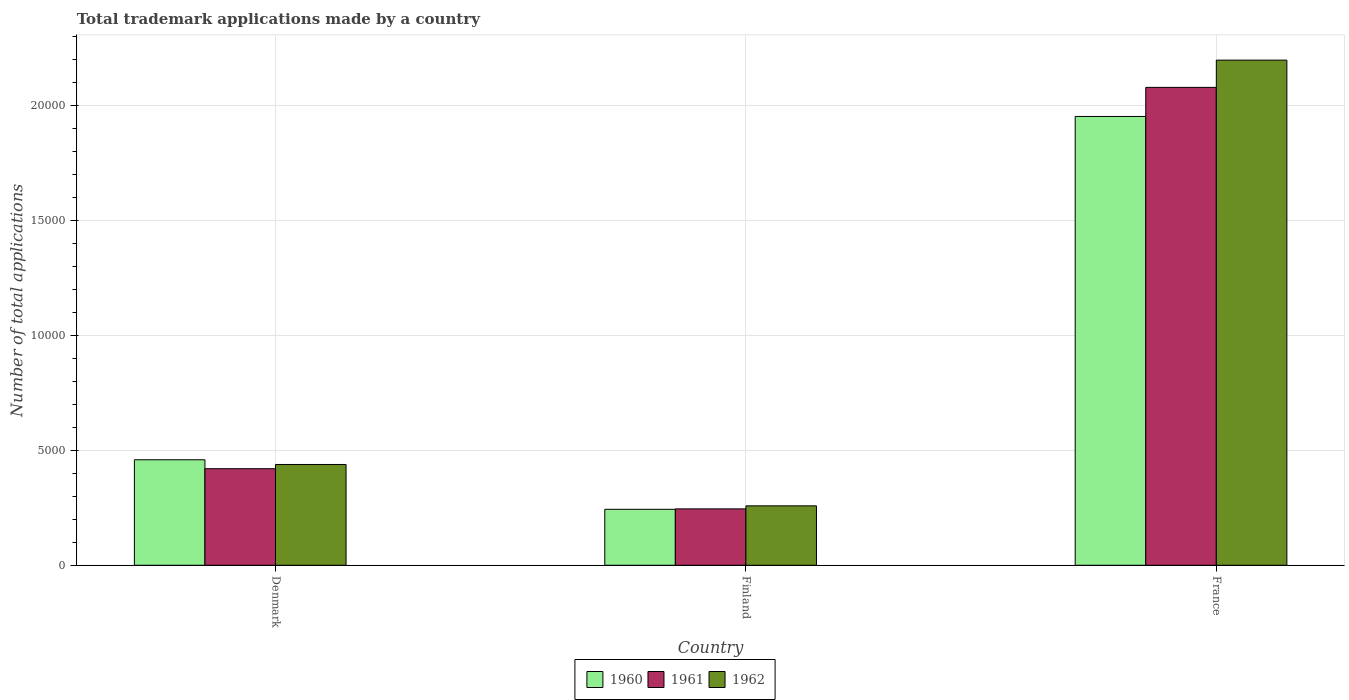How many different coloured bars are there?
Make the answer very short. 3. Are the number of bars per tick equal to the number of legend labels?
Give a very brief answer. Yes. Are the number of bars on each tick of the X-axis equal?
Provide a succinct answer. Yes. How many bars are there on the 3rd tick from the right?
Offer a terse response. 3. What is the number of applications made by in 1961 in France?
Keep it short and to the point. 2.08e+04. Across all countries, what is the maximum number of applications made by in 1962?
Your response must be concise. 2.20e+04. Across all countries, what is the minimum number of applications made by in 1960?
Ensure brevity in your answer.  2432. In which country was the number of applications made by in 1960 minimum?
Ensure brevity in your answer.  Finland. What is the total number of applications made by in 1960 in the graph?
Keep it short and to the point. 2.65e+04. What is the difference between the number of applications made by in 1962 in Finland and that in France?
Offer a very short reply. -1.94e+04. What is the difference between the number of applications made by in 1961 in Finland and the number of applications made by in 1962 in Denmark?
Ensure brevity in your answer.  -1930. What is the average number of applications made by in 1961 per country?
Your response must be concise. 9138. What is the difference between the number of applications made by of/in 1961 and number of applications made by of/in 1960 in France?
Offer a very short reply. 1264. What is the ratio of the number of applications made by in 1960 in Denmark to that in France?
Offer a terse response. 0.24. Is the number of applications made by in 1961 in Denmark less than that in Finland?
Keep it short and to the point. No. What is the difference between the highest and the second highest number of applications made by in 1962?
Offer a very short reply. 1.76e+04. What is the difference between the highest and the lowest number of applications made by in 1962?
Give a very brief answer. 1.94e+04. Is the sum of the number of applications made by in 1960 in Finland and France greater than the maximum number of applications made by in 1961 across all countries?
Provide a succinct answer. Yes. What does the 1st bar from the left in Denmark represents?
Your response must be concise. 1960. What does the 3rd bar from the right in France represents?
Your answer should be very brief. 1960. Is it the case that in every country, the sum of the number of applications made by in 1961 and number of applications made by in 1960 is greater than the number of applications made by in 1962?
Keep it short and to the point. Yes. How many bars are there?
Provide a short and direct response. 9. Are the values on the major ticks of Y-axis written in scientific E-notation?
Keep it short and to the point. No. Does the graph contain any zero values?
Offer a terse response. No. Does the graph contain grids?
Your answer should be compact. Yes. Where does the legend appear in the graph?
Ensure brevity in your answer.  Bottom center. What is the title of the graph?
Make the answer very short. Total trademark applications made by a country. Does "2015" appear as one of the legend labels in the graph?
Offer a very short reply. No. What is the label or title of the X-axis?
Make the answer very short. Country. What is the label or title of the Y-axis?
Your answer should be very brief. Number of total applications. What is the Number of total applications in 1960 in Denmark?
Offer a terse response. 4584. What is the Number of total applications of 1961 in Denmark?
Your answer should be compact. 4196. What is the Number of total applications in 1962 in Denmark?
Ensure brevity in your answer.  4380. What is the Number of total applications of 1960 in Finland?
Provide a short and direct response. 2432. What is the Number of total applications of 1961 in Finland?
Keep it short and to the point. 2450. What is the Number of total applications in 1962 in Finland?
Offer a very short reply. 2582. What is the Number of total applications in 1960 in France?
Give a very brief answer. 1.95e+04. What is the Number of total applications of 1961 in France?
Provide a short and direct response. 2.08e+04. What is the Number of total applications in 1962 in France?
Ensure brevity in your answer.  2.20e+04. Across all countries, what is the maximum Number of total applications in 1960?
Your response must be concise. 1.95e+04. Across all countries, what is the maximum Number of total applications of 1961?
Offer a terse response. 2.08e+04. Across all countries, what is the maximum Number of total applications in 1962?
Your response must be concise. 2.20e+04. Across all countries, what is the minimum Number of total applications in 1960?
Your answer should be very brief. 2432. Across all countries, what is the minimum Number of total applications in 1961?
Keep it short and to the point. 2450. Across all countries, what is the minimum Number of total applications in 1962?
Your answer should be very brief. 2582. What is the total Number of total applications in 1960 in the graph?
Keep it short and to the point. 2.65e+04. What is the total Number of total applications of 1961 in the graph?
Ensure brevity in your answer.  2.74e+04. What is the total Number of total applications in 1962 in the graph?
Provide a succinct answer. 2.89e+04. What is the difference between the Number of total applications of 1960 in Denmark and that in Finland?
Your answer should be compact. 2152. What is the difference between the Number of total applications of 1961 in Denmark and that in Finland?
Your answer should be compact. 1746. What is the difference between the Number of total applications in 1962 in Denmark and that in Finland?
Your answer should be compact. 1798. What is the difference between the Number of total applications in 1960 in Denmark and that in France?
Provide a short and direct response. -1.49e+04. What is the difference between the Number of total applications in 1961 in Denmark and that in France?
Your response must be concise. -1.66e+04. What is the difference between the Number of total applications of 1962 in Denmark and that in France?
Offer a very short reply. -1.76e+04. What is the difference between the Number of total applications in 1960 in Finland and that in France?
Ensure brevity in your answer.  -1.71e+04. What is the difference between the Number of total applications of 1961 in Finland and that in France?
Offer a very short reply. -1.83e+04. What is the difference between the Number of total applications in 1962 in Finland and that in France?
Your response must be concise. -1.94e+04. What is the difference between the Number of total applications of 1960 in Denmark and the Number of total applications of 1961 in Finland?
Ensure brevity in your answer.  2134. What is the difference between the Number of total applications of 1960 in Denmark and the Number of total applications of 1962 in Finland?
Your answer should be very brief. 2002. What is the difference between the Number of total applications in 1961 in Denmark and the Number of total applications in 1962 in Finland?
Make the answer very short. 1614. What is the difference between the Number of total applications of 1960 in Denmark and the Number of total applications of 1961 in France?
Make the answer very short. -1.62e+04. What is the difference between the Number of total applications of 1960 in Denmark and the Number of total applications of 1962 in France?
Make the answer very short. -1.74e+04. What is the difference between the Number of total applications of 1961 in Denmark and the Number of total applications of 1962 in France?
Provide a succinct answer. -1.78e+04. What is the difference between the Number of total applications in 1960 in Finland and the Number of total applications in 1961 in France?
Provide a succinct answer. -1.83e+04. What is the difference between the Number of total applications in 1960 in Finland and the Number of total applications in 1962 in France?
Your answer should be very brief. -1.95e+04. What is the difference between the Number of total applications in 1961 in Finland and the Number of total applications in 1962 in France?
Your response must be concise. -1.95e+04. What is the average Number of total applications in 1960 per country?
Your response must be concise. 8840. What is the average Number of total applications of 1961 per country?
Provide a short and direct response. 9138. What is the average Number of total applications in 1962 per country?
Provide a succinct answer. 9638. What is the difference between the Number of total applications of 1960 and Number of total applications of 1961 in Denmark?
Provide a succinct answer. 388. What is the difference between the Number of total applications in 1960 and Number of total applications in 1962 in Denmark?
Give a very brief answer. 204. What is the difference between the Number of total applications of 1961 and Number of total applications of 1962 in Denmark?
Your response must be concise. -184. What is the difference between the Number of total applications of 1960 and Number of total applications of 1962 in Finland?
Ensure brevity in your answer.  -150. What is the difference between the Number of total applications of 1961 and Number of total applications of 1962 in Finland?
Offer a terse response. -132. What is the difference between the Number of total applications in 1960 and Number of total applications in 1961 in France?
Offer a very short reply. -1264. What is the difference between the Number of total applications in 1960 and Number of total applications in 1962 in France?
Provide a succinct answer. -2448. What is the difference between the Number of total applications of 1961 and Number of total applications of 1962 in France?
Ensure brevity in your answer.  -1184. What is the ratio of the Number of total applications of 1960 in Denmark to that in Finland?
Offer a very short reply. 1.88. What is the ratio of the Number of total applications in 1961 in Denmark to that in Finland?
Make the answer very short. 1.71. What is the ratio of the Number of total applications in 1962 in Denmark to that in Finland?
Provide a short and direct response. 1.7. What is the ratio of the Number of total applications in 1960 in Denmark to that in France?
Your answer should be compact. 0.23. What is the ratio of the Number of total applications in 1961 in Denmark to that in France?
Keep it short and to the point. 0.2. What is the ratio of the Number of total applications in 1962 in Denmark to that in France?
Offer a terse response. 0.2. What is the ratio of the Number of total applications in 1960 in Finland to that in France?
Keep it short and to the point. 0.12. What is the ratio of the Number of total applications in 1961 in Finland to that in France?
Ensure brevity in your answer.  0.12. What is the ratio of the Number of total applications in 1962 in Finland to that in France?
Ensure brevity in your answer.  0.12. What is the difference between the highest and the second highest Number of total applications in 1960?
Keep it short and to the point. 1.49e+04. What is the difference between the highest and the second highest Number of total applications in 1961?
Ensure brevity in your answer.  1.66e+04. What is the difference between the highest and the second highest Number of total applications in 1962?
Offer a very short reply. 1.76e+04. What is the difference between the highest and the lowest Number of total applications of 1960?
Provide a short and direct response. 1.71e+04. What is the difference between the highest and the lowest Number of total applications in 1961?
Provide a succinct answer. 1.83e+04. What is the difference between the highest and the lowest Number of total applications in 1962?
Your answer should be compact. 1.94e+04. 